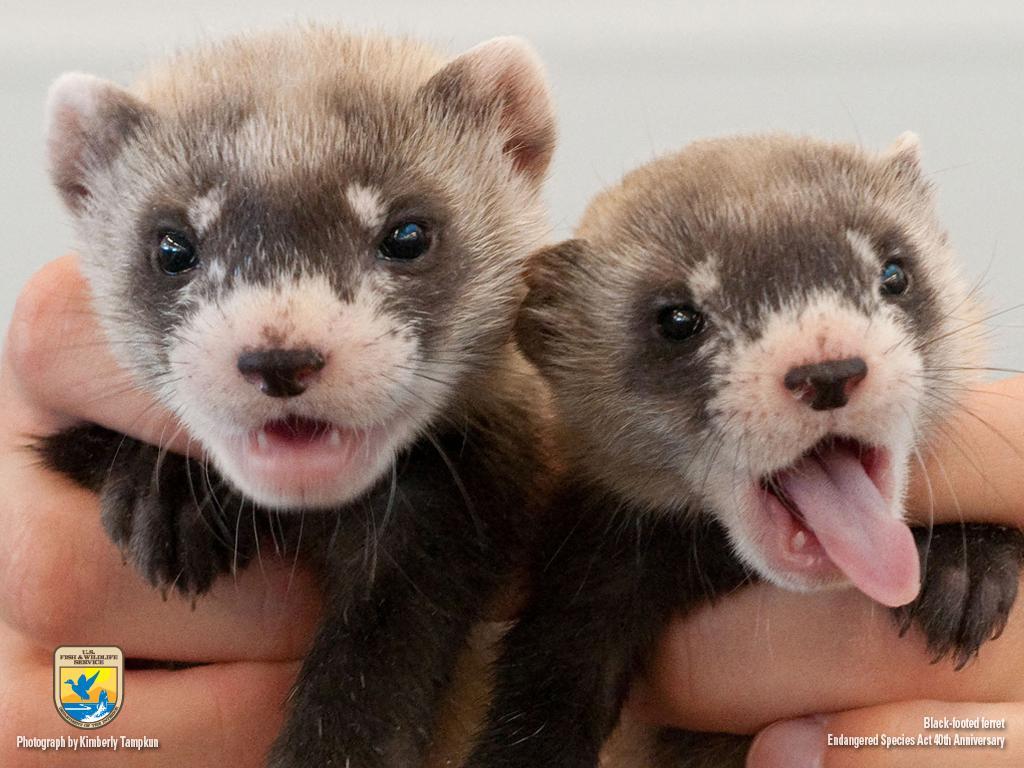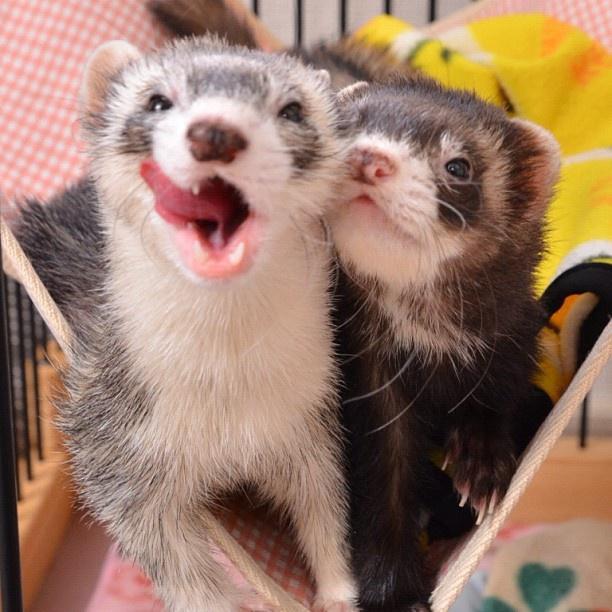The first image is the image on the left, the second image is the image on the right. Assess this claim about the two images: "The combined images contain four ferrets, at least three ferrets have raccoon-mask markings, and a human hand is grasping at least one ferret.". Correct or not? Answer yes or no. Yes. The first image is the image on the left, the second image is the image on the right. Given the left and right images, does the statement "In one of the images there is one animal being held." hold true? Answer yes or no. No. 